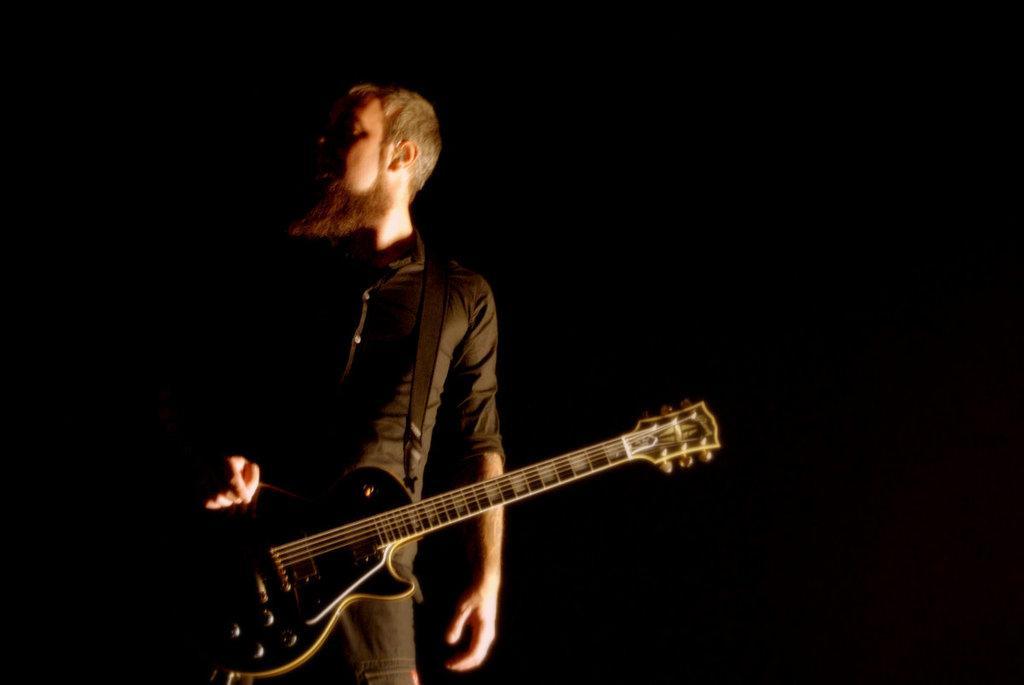Can you describe this image briefly? Here we can see a person with a guitar with him 